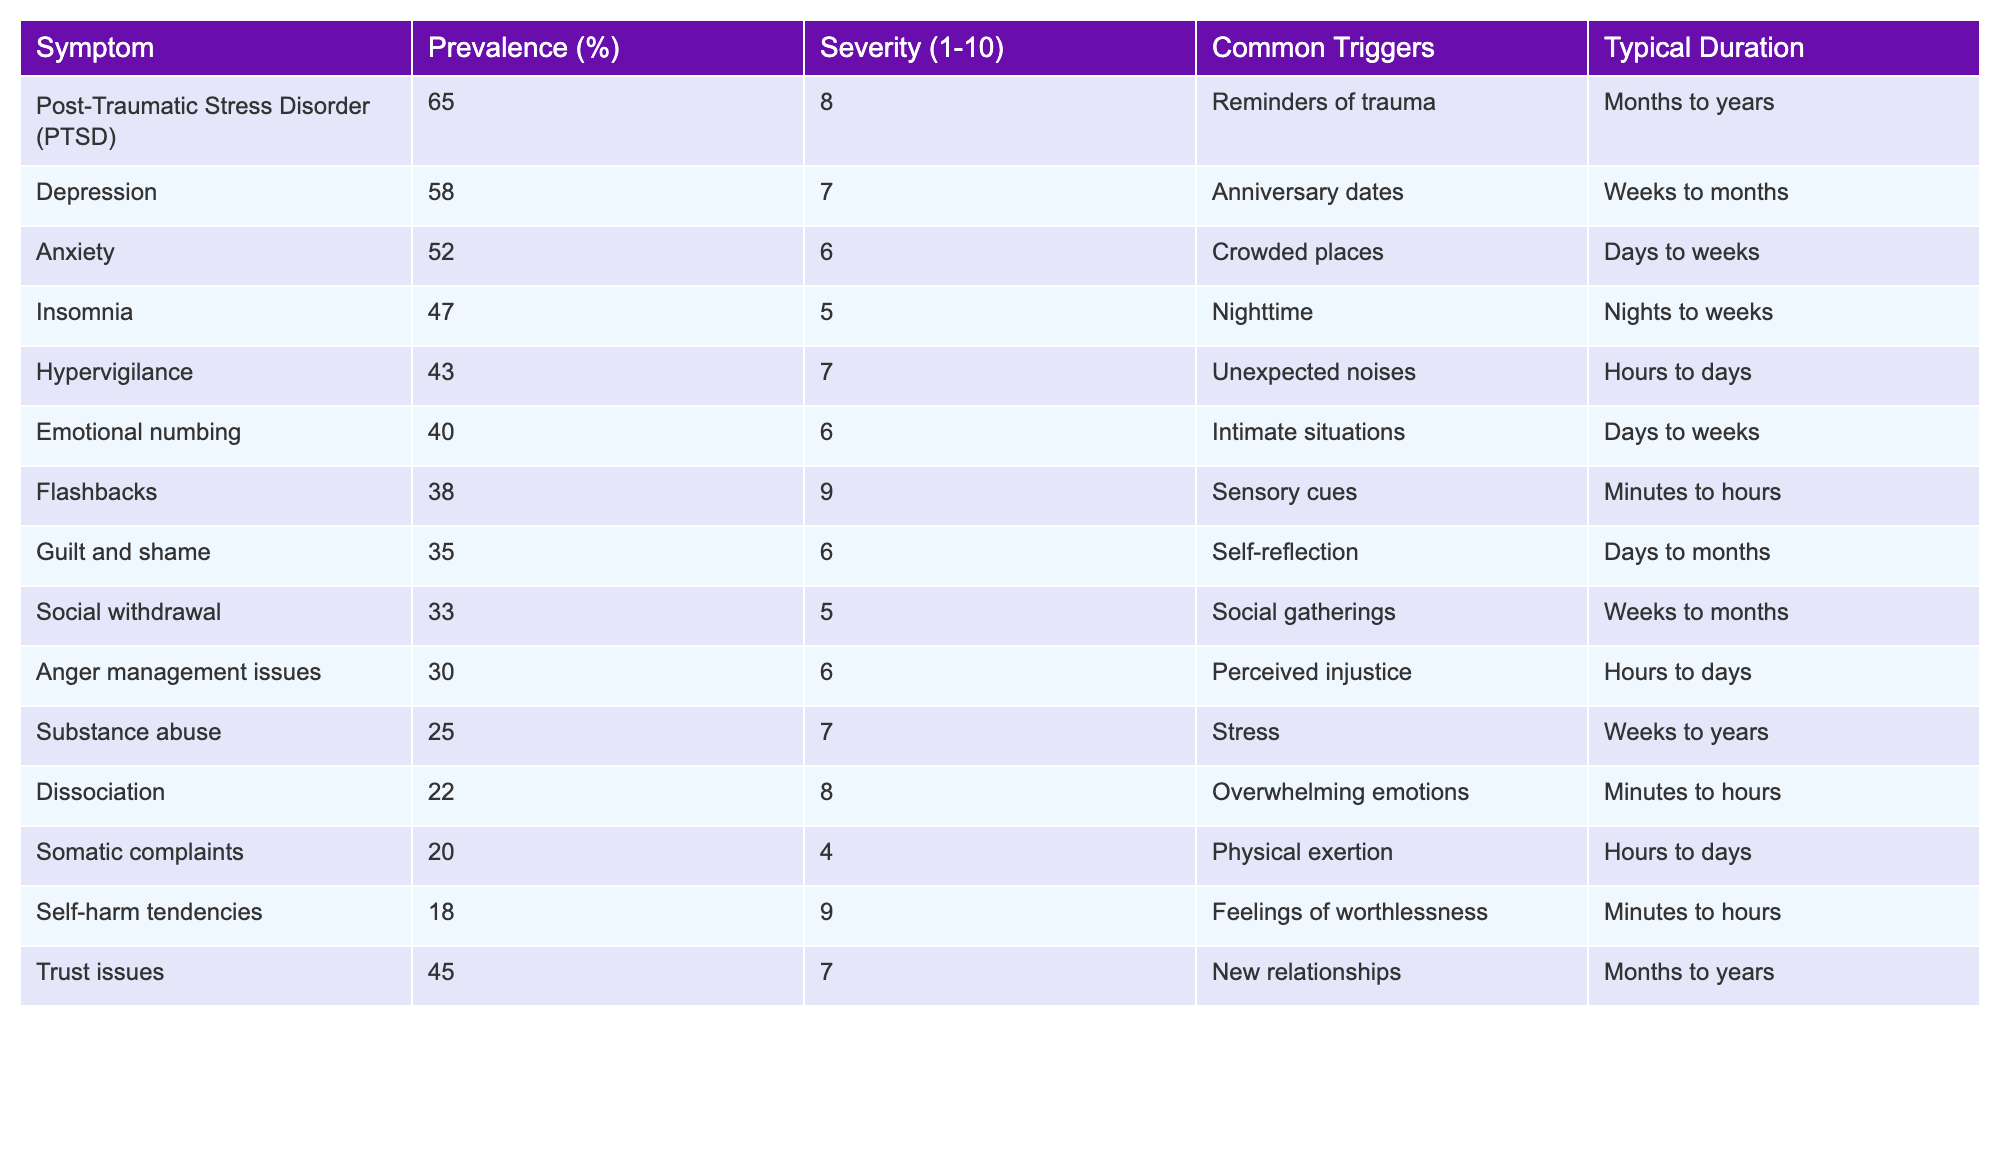What is the prevalence percentage of Post-Traumatic Stress Disorder (PTSD)? The table shows that the prevalence percentage of PTSD is listed directly under the "Prevalence (%)" column. It states 65% for PTSD.
Answer: 65% Which symptom has the highest severity rating? By examining the "Severity (1-10)" column, PTSD has the highest severity rating of 8.
Answer: PTSD What is the typical duration for symptoms of Insomnia? The "Typical Duration" column indicates that the typical duration for Insomnia is "Nights to weeks."
Answer: Nights to weeks Is the prevalence of Anxiety higher than that of Depression? By comparing the "Prevalence (%)" values for both symptoms, Anxiety is at 52% while Depression is at 58%. Therefore, Anxiety is lower than Depression.
Answer: No What is the average severity rating of symptoms with prevalence above 30%? The symptoms with prevalence above 30% are PTSD (8), Depression (7), Anxiety (6), Hypervigilance (7), Emotional numbing (6), Guilt and shame (6), Social withdrawal (5), and Trust issues (7). Their total severity is 8 + 7 + 6 + 7 + 6 + 6 + 5 + 7 = 52. There are 8 symptoms, so the average severity rating is 52/8 = 6.5.
Answer: 6.5 Which common trigger is associated with the symptom of Flashbacks? Flashbacks have the common trigger listed as "Sensory cues." This information can be found directly in the "Common Triggers" column for Flashbacks.
Answer: Sensory cues Identify a symptom that has a prevalence above 40% and a severity of at least 7. The symptoms with a prevalence above 40% and severity of at least 7 are PTSD (65%, 8) and Trust issues (45%, 7). Both meet the criteria.
Answer: PTSD and Trust issues What is the difference in prevalence percentage between Guilt and shame and Substance abuse? Guilt and shame has a prevalence of 35%, and Substance abuse has a prevalence of 25%. The difference is calculated as 35% - 25% = 10%.
Answer: 10% Which symptom lasts the longest on average based on the typical duration? By evaluating the typical duration listed in the table, both PTSD and Trust issues are stated as lasting "Months to years," indicating a longer duration compared to other symptoms.
Answer: PTSD and Trust issues Is Emotional numbing associated with social gatherings as a common trigger? The table shows that Emotional numbing is triggered by "Intimate situations," not social gatherings. Therefore, the statement is false.
Answer: No 